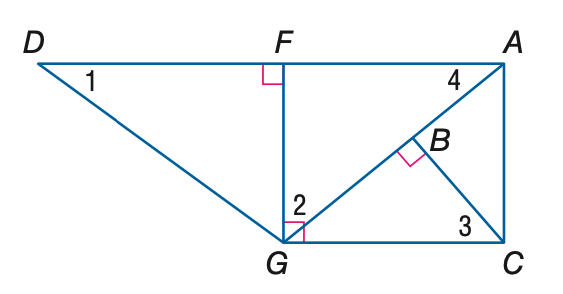Answer the mathemtical geometry problem and directly provide the correct option letter.
Question: Find the measure of \angle 1 if m \angle D G F = 53 and m \angle A G C = 40.
Choices: A: 37 B: 40 C: 50 D: 53 A 